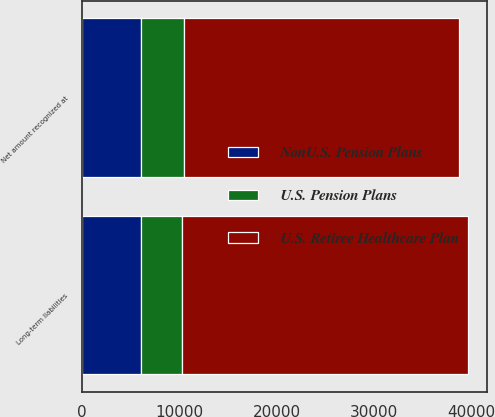Convert chart to OTSL. <chart><loc_0><loc_0><loc_500><loc_500><stacked_bar_chart><ecel><fcel>Long-term liabilities<fcel>Net amount recognized at<nl><fcel>NonU.S. Pension Plans<fcel>6077<fcel>6077<nl><fcel>U.S. Pension Plans<fcel>4142<fcel>4404<nl><fcel>U.S. Retiree Healthcare Plan<fcel>29473<fcel>28296<nl></chart> 